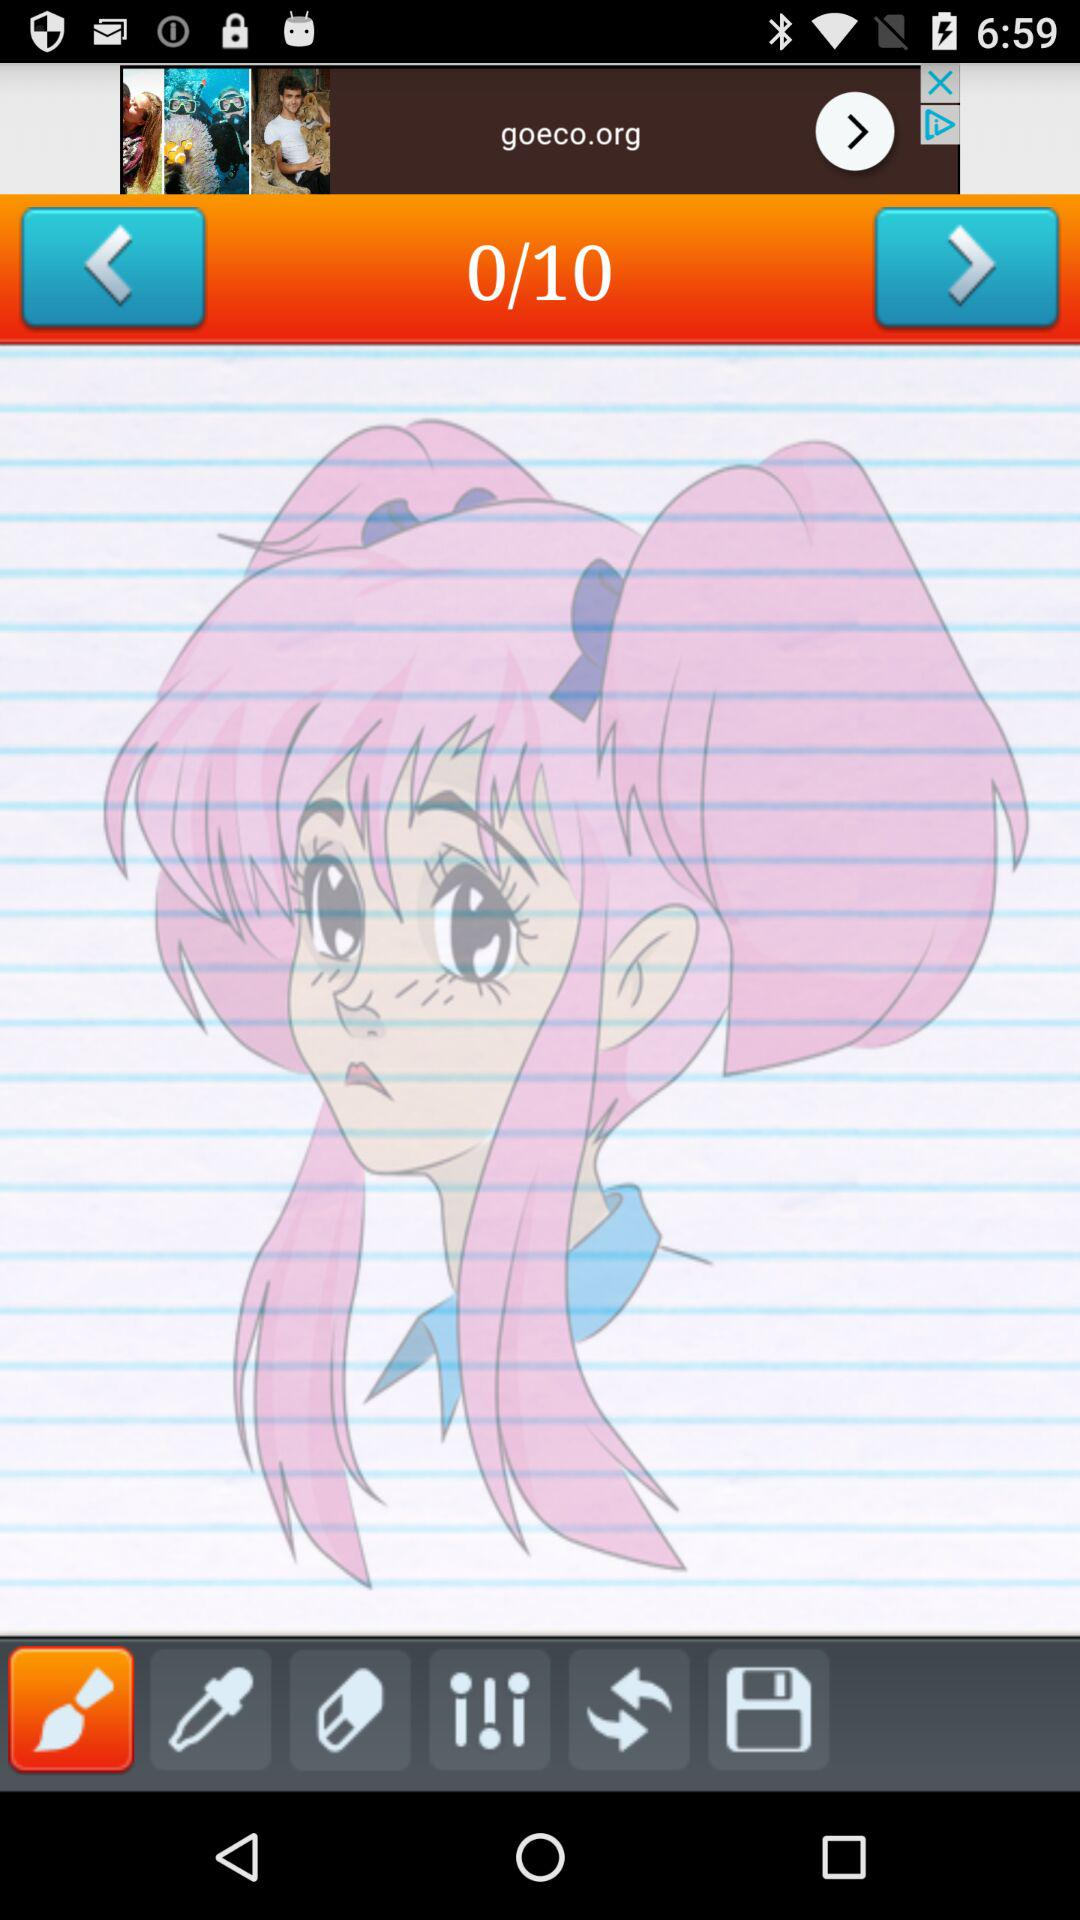Which page are we on? You are on page 0. 